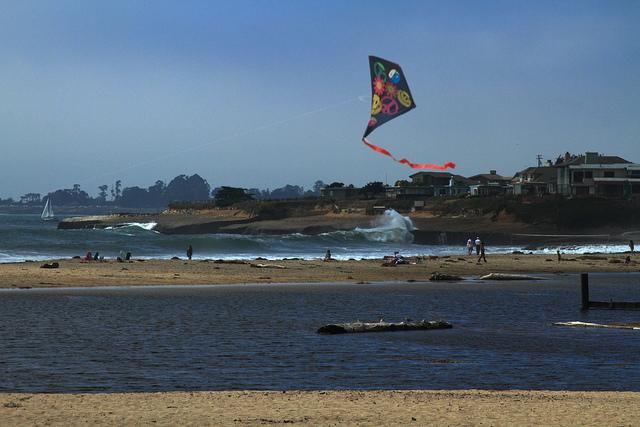How many trees are under the blue sky?
Answer briefly. 10. What are the people in the picture walking on?
Concise answer only. Beach. Is the water continuous?
Be succinct. No. 